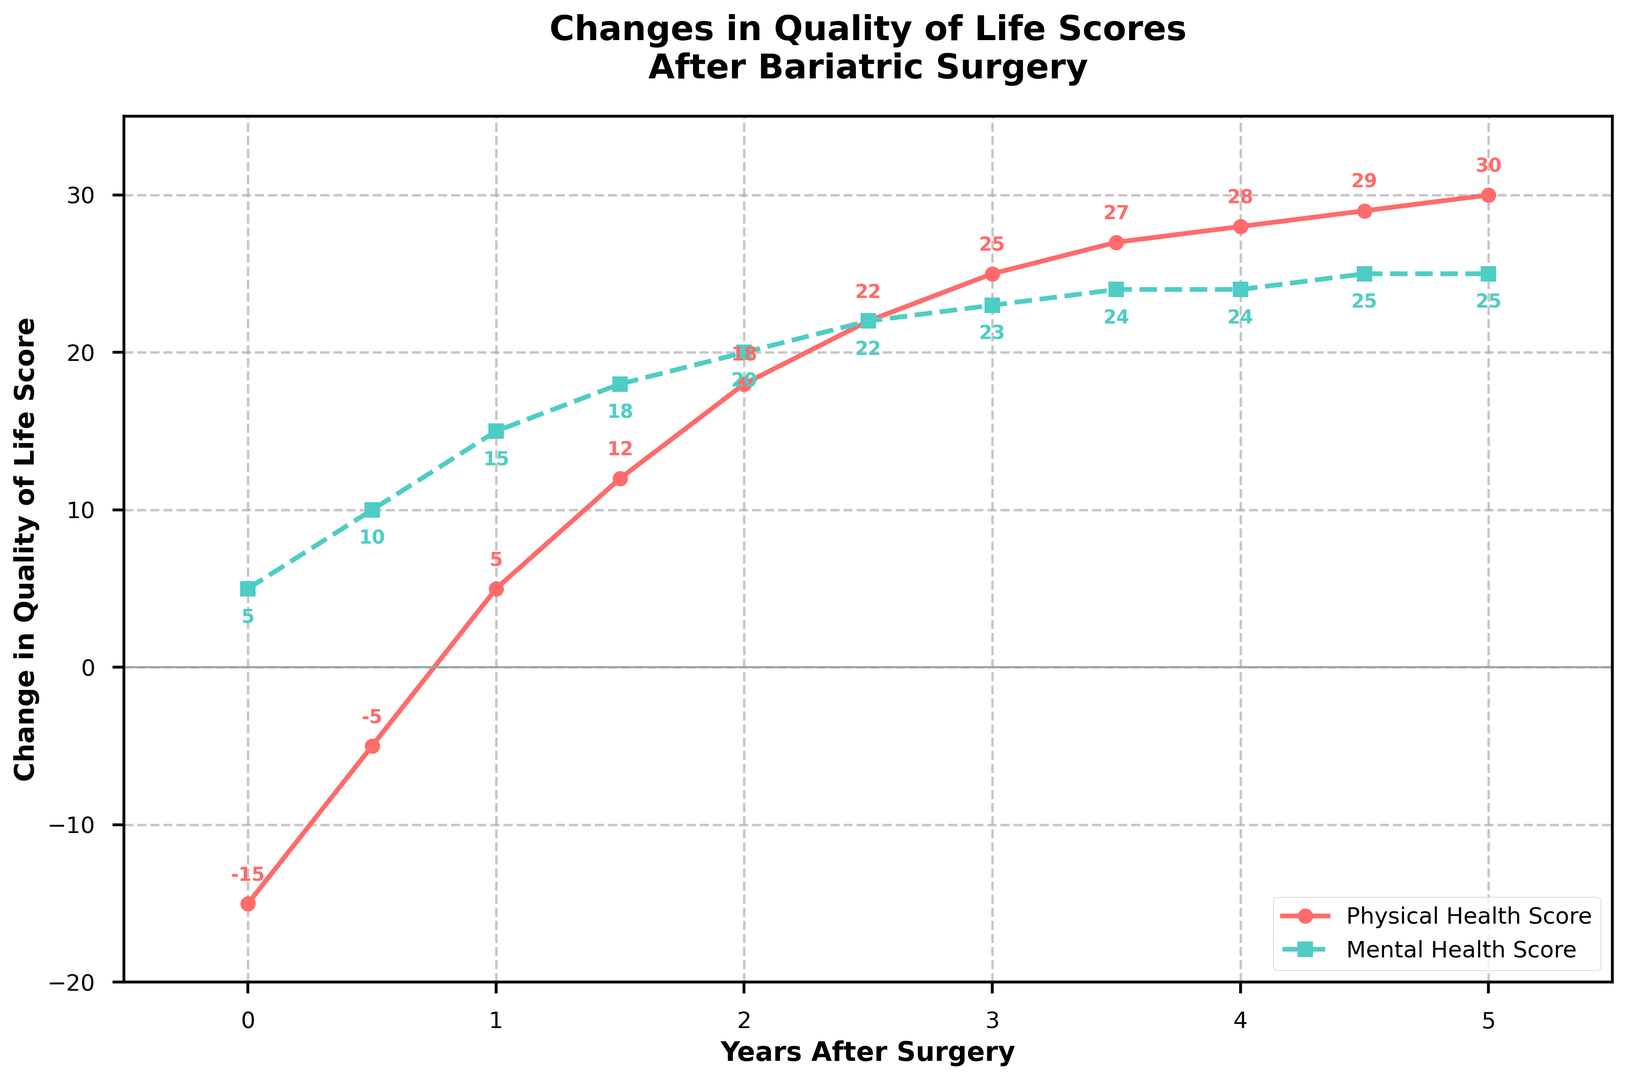What's the overall trend in the Physical Health Score over the 5-year period? The Physical Health Score starts at -15 at year 0, increases steadily each year, and reaches 30 by year 5. This indicates a consistent improvement in physical health post-surgery.
Answer: Improvement How does the trend in Mental Health Score differ from the Physical Health Score trend? The Mental Health Score starts at 5 at year 0 and increases more slowly compared to Physical Health Score, reaching 25 by year 5. While both scores improve, the Physical Health Score shows a steeper increase.
Answer: Slower improvement At which year does the Physical Health Score first become positive? The Physical Health Score transitions from negative to positive between years 0.5 and 1. At year 1, it is 5.
Answer: Year 1 Which score shows a faster initial improvement within the first year after surgery? Within the first year, the Physical Health Score increases from -15 to 5, a change of 20 points. The Mental Health Score increases from 5 to 15, a change of 10 points. Therefore, the Physical Health Score shows a faster initial improvement.
Answer: Physical Health Score What is the difference between the Mental Health Score and the Physical Health Score at Year 3? At Year 3, the Physical Health Score is 25 and the Mental Health Score is 23. The difference is 25 - 23 = 2.
Answer: 2 How many years does it take for the Physical Health Score to surpass 20? The Physical Health Score surpasses 20 between years 2 and 2.5. At Year 2, it is 18; at Year 2.5, it is 22.
Answer: 2.5 years At which points are the Physical and Mental Health Scores equal? The scores are equal when they intersect on the graph. However, in this dataset, they do not intersect at any point within the given 5-year period.
Answer: They do not intersect What is the average improvement per year in the Mental Health Score from Year 0 to Year 5? The Mental Health Score starts at 5 and ends at 25 over 5 years. The total improvement is 25 - 5 = 20 points. The average annual improvement is 20 / 5 = 4 points per year.
Answer: 4 points per year By how much does the Physical Health Score improve from Year 0 to Year 2? The Physical Health Score improves from -15 at Year 0 to 18 at Year 2. The improvement is 18 - (-15) = 33 points.
Answer: 33 points 